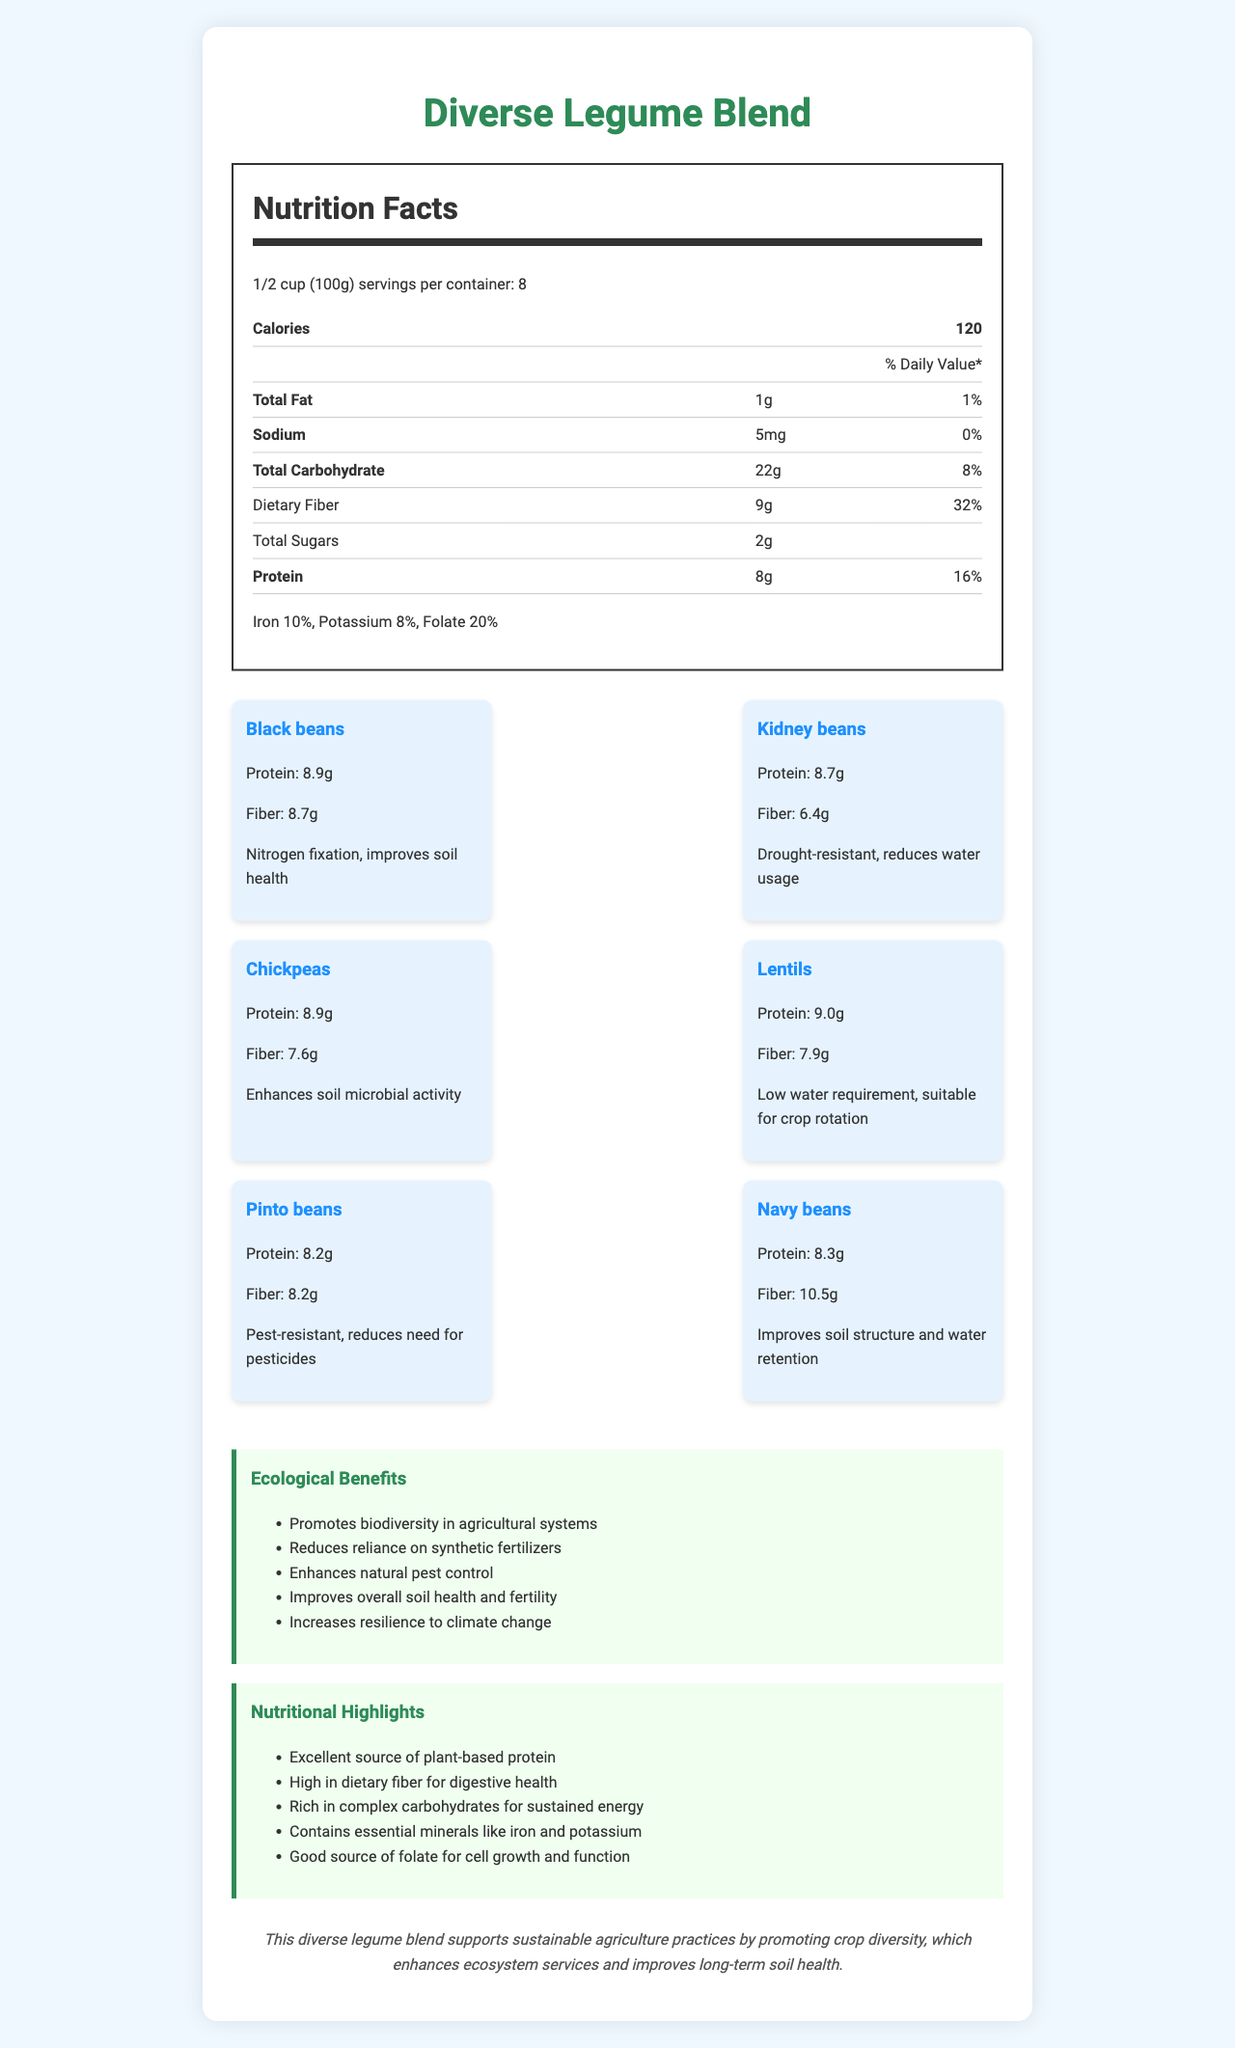What is the serving size for the Diverse Legume Blend? The document states that the serving size for the Diverse Legume Blend is 1/2 cup (100g).
Answer: 1/2 cup (100g) How many servings are there per container? The document mentions that there are 8 servings per container.
Answer: 8 What is the amount of protein per serving? The nutrition facts section lists the amount of protein per serving as 8g.
Answer: 8g How much dietary fiber is in one serving? The nutrition facts table shows that there is 9g of dietary fiber per serving.
Answer: 9g Which legume species contains the highest amount of fiber per 100g? The bean species breakdown shows Navy beans contain 10.5g of fiber per 100g, which is the highest among the listed species.
Answer: Navy beans Which bean species is known for improving soil health through nitrogen fixation? A. Kidney beans B. Lentils C. Black beans D. Chickpeas According to the document, Black beans are known for their nitrogen fixation ability which improves soil health.
Answer: C. Black beans Which of the following beans have the lowest water requirement? I. Lentils II. Kidney beans III. Chickpeas The bean species breakdown mentions that Lentils have a low water requirement and are suitable for crop rotation.
Answer: I. Lentils Is this product an excellent source of plant-based protein? The nutritional highlights section states that the Diverse Legume Blend is an excellent source of plant-based protein.
Answer: Yes Does the legume blend support sustainable agriculture practices? The sustainability note mentions that this blend supports sustainable agriculture practices by promoting crop diversity.
Answer: Yes Summarize the key ecological and nutritional benefits of the Diverse Legume Blend. The document lists high amounts of plant-based protein and dietary fiber. It highlights ecological advantages like nitrogen fixation, soil health improvement, low water requirements, pest resistance, and contributions to sustainable agriculture.
Answer: The Diverse Legume Blend offers high protein and fiber content, enhances soil health, promotes biodiversity, reduces reliance on synthetic fertilizers, and increases resilience to climate change. What is the daily value percentage of potassium in the legume blend? The list of vitamins and minerals includes potassium with a daily value percentage of 8%.
Answer: 8% What ecological benefit is associated with Pest-resistance in beans? The bean species breakdown notes that Pinto beans, which are pest-resistant, reduce the need for pesticides.
Answer: Reduces the need for pesticides Which legume has the least protein content? The bean species breakdown shows that Pinto beans have the least protein content at 8.2g per 100g compared to other legumes in the blend.
Answer: Pinto beans How much fat is in one serving of the legume blend? The nutrition facts section states that each serving contains 1g of total fat.
Answer: 1g Which vitamin mentioned in the document is essential for cell growth and function? The nutritional highlights mention folate as a good source for cell growth and function.
Answer: Folate Can you determine the brand or manufacturer of the Diverse Legume Blend based on the document? The document provides detailed nutritional and ecological information about the Diverse Legume Blend but does not mention the brand or manufacturer.
Answer: Not enough information 